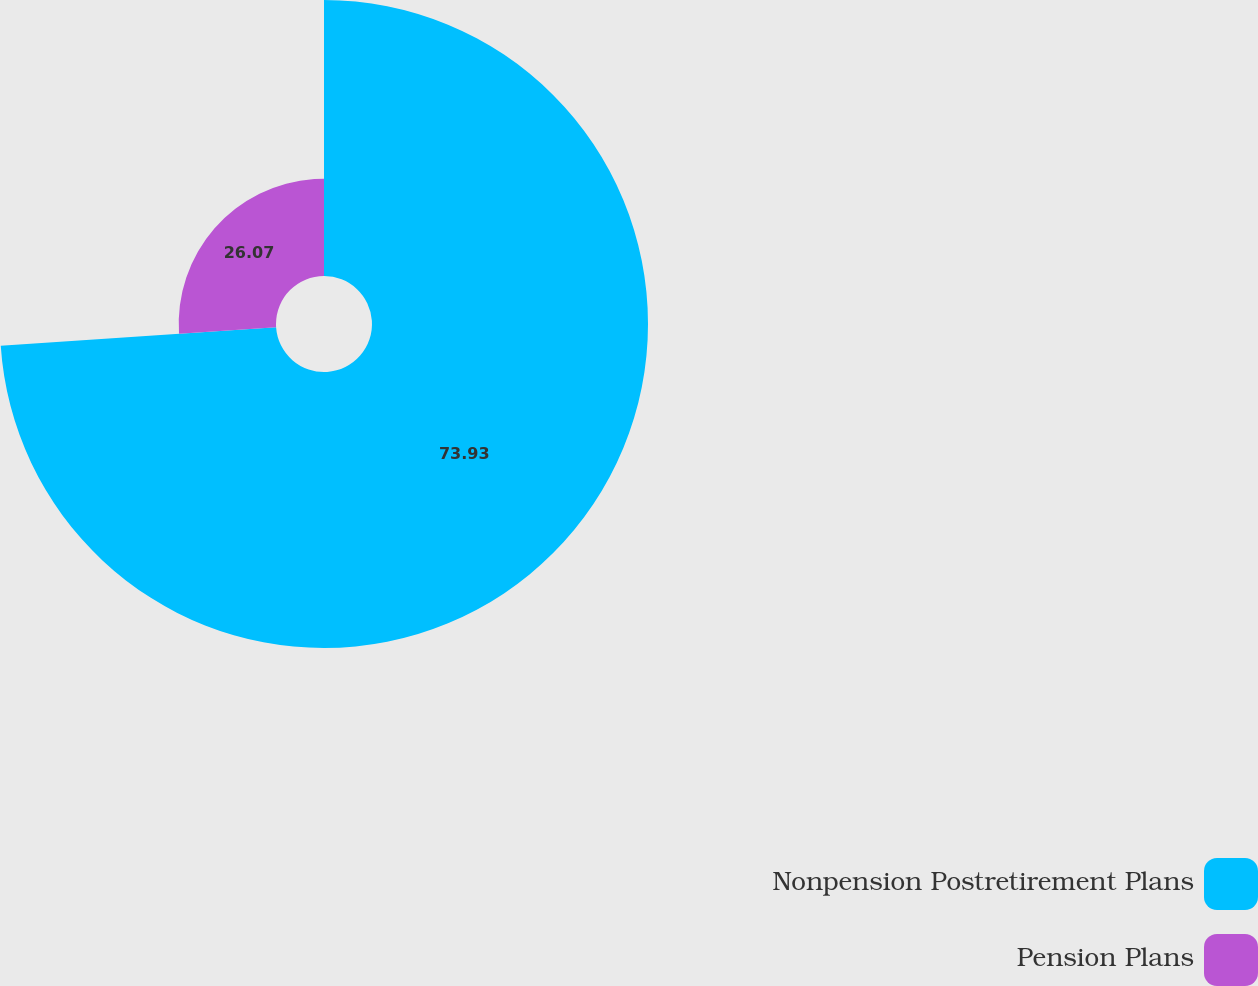Convert chart to OTSL. <chart><loc_0><loc_0><loc_500><loc_500><pie_chart><fcel>Nonpension Postretirement Plans<fcel>Pension Plans<nl><fcel>73.93%<fcel>26.07%<nl></chart> 